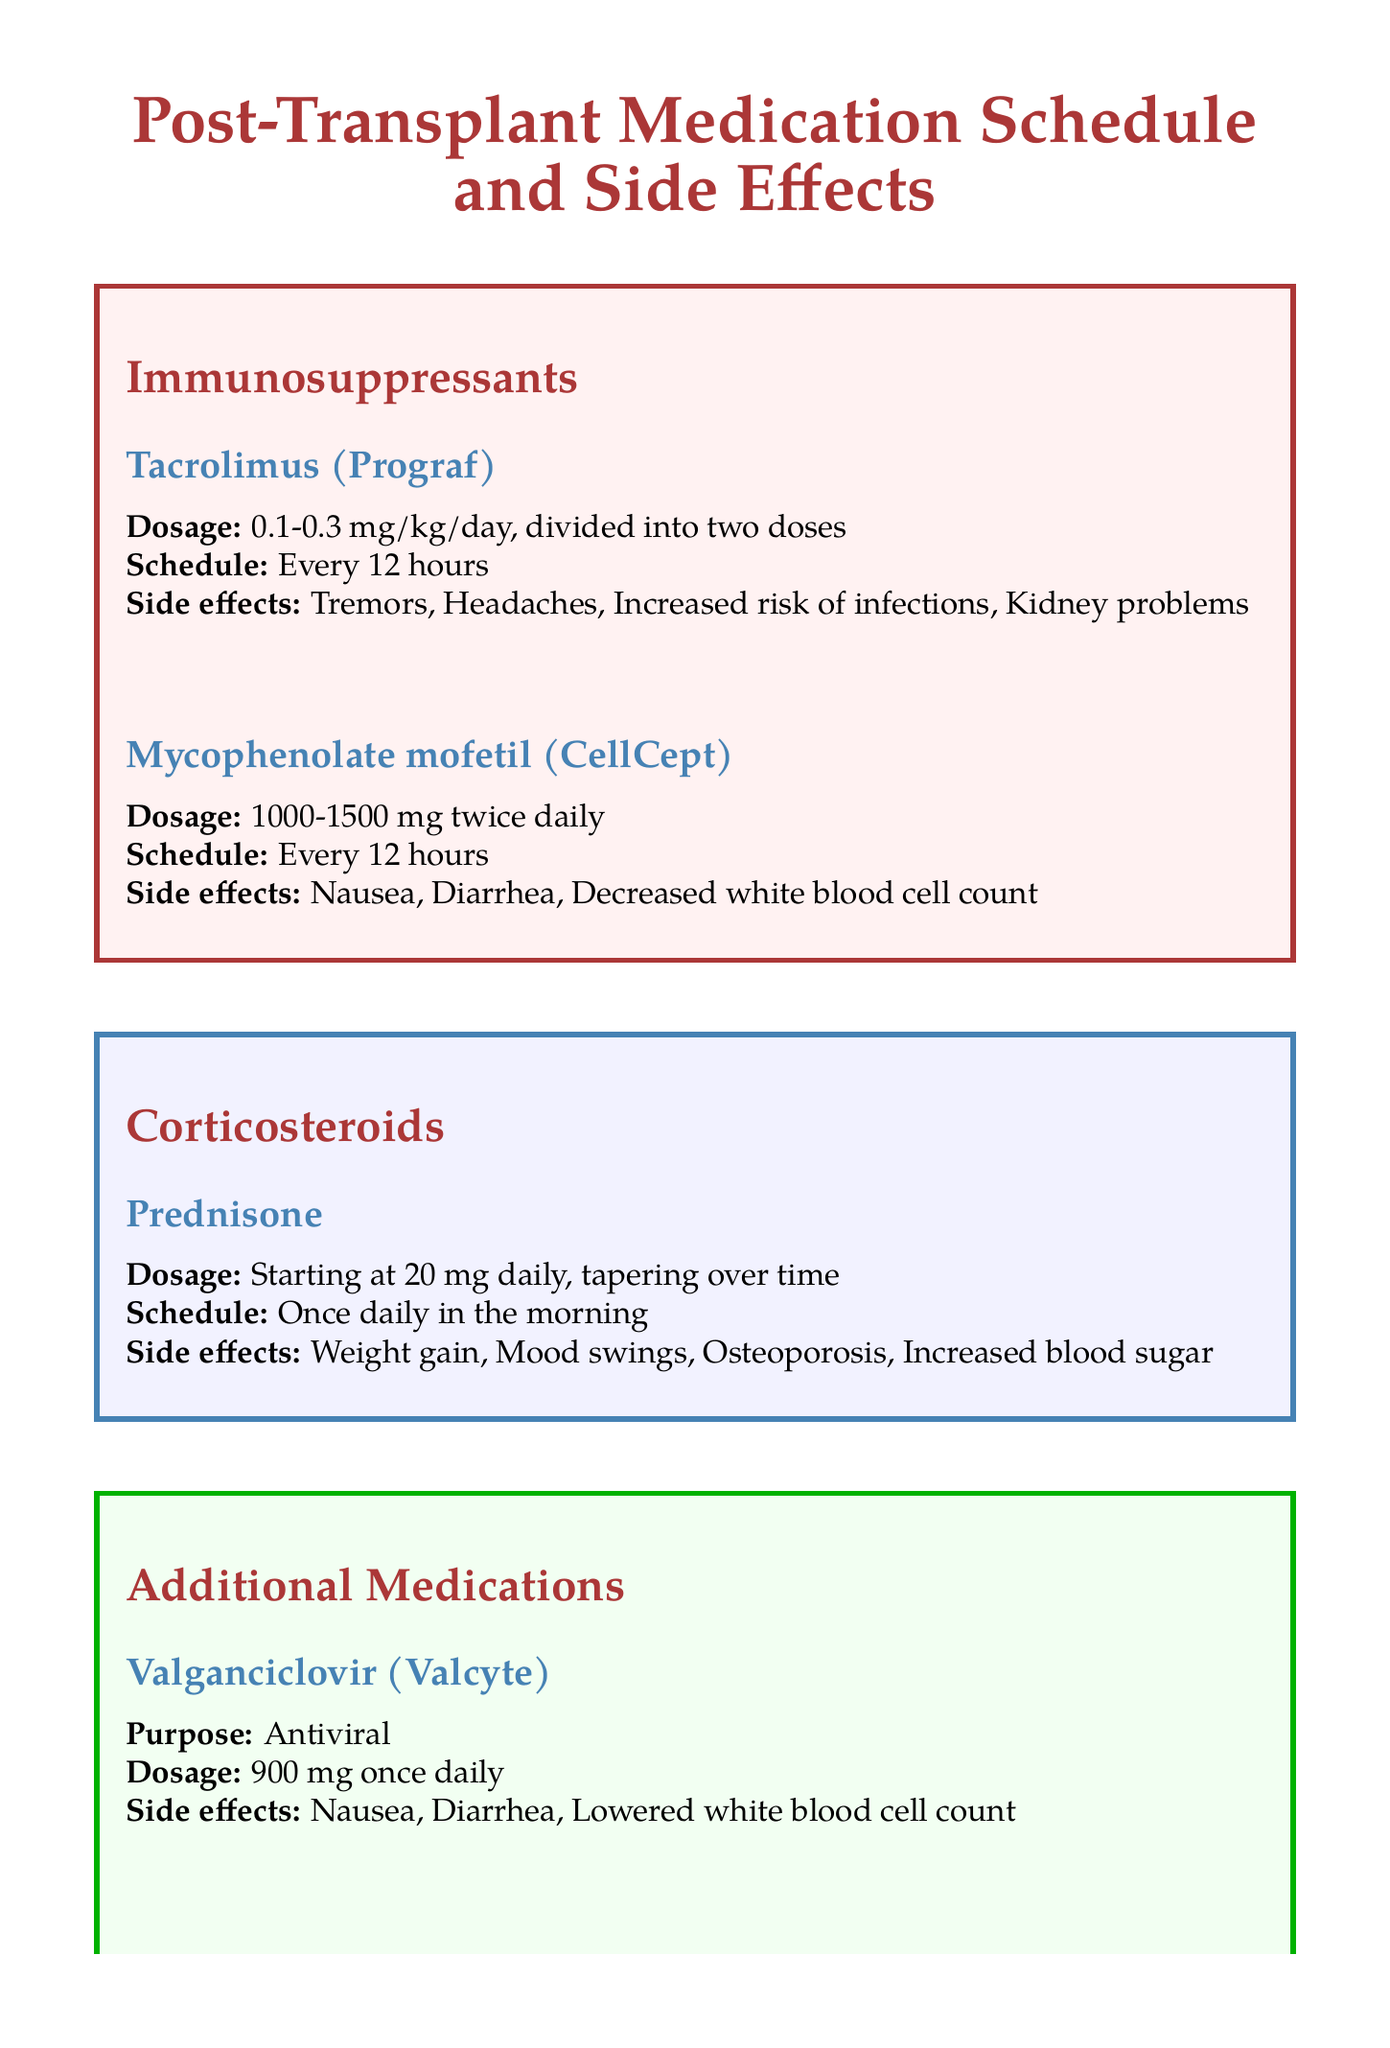What is the dosage for Tacrolimus? The dosage for Tacrolimus is specified in the document as between 0.1-0.3 mg/kg/day.
Answer: 0.1-0.3 mg/kg/day How often should Mycophenolate mofetil be taken? The document states that Mycophenolate mofetil should be taken every 12 hours.
Answer: Every 12 hours What is a common side effect of Prednisone? The document lists weight gain as a common side effect of Prednisone.
Answer: Weight gain What should be done for monitoring after transplant? The document recommends regular blood tests and monthly check-ups with the transplant team for the first year.
Answer: Regular blood tests and monthly check-ups Which medication serves as an antiviral? The medication Valganciclovir (Valcyte) is described as an antiviral in the document.
Answer: Valganciclovir (Valcyte) What lifestyle consideration is advised regarding grapefruit? The document advises avoiding grapefruit and grapefruit juice due to their interaction with medications.
Answer: Avoid grapefruit and grapefruit juice What is the purpose of Trimethoprim-sulfamethoxazole? According to the document, Trimethoprim-sulfamethoxazole is an antibiotic.
Answer: Antibiotic How long should the medication diary be maintained? The document does not specify a duration but encourages maintaining a medication diary.
Answer: Ongoing What is the starting dosage for Prednisone? The document states that Prednisone starts at 20 mg daily.
Answer: 20 mg daily 